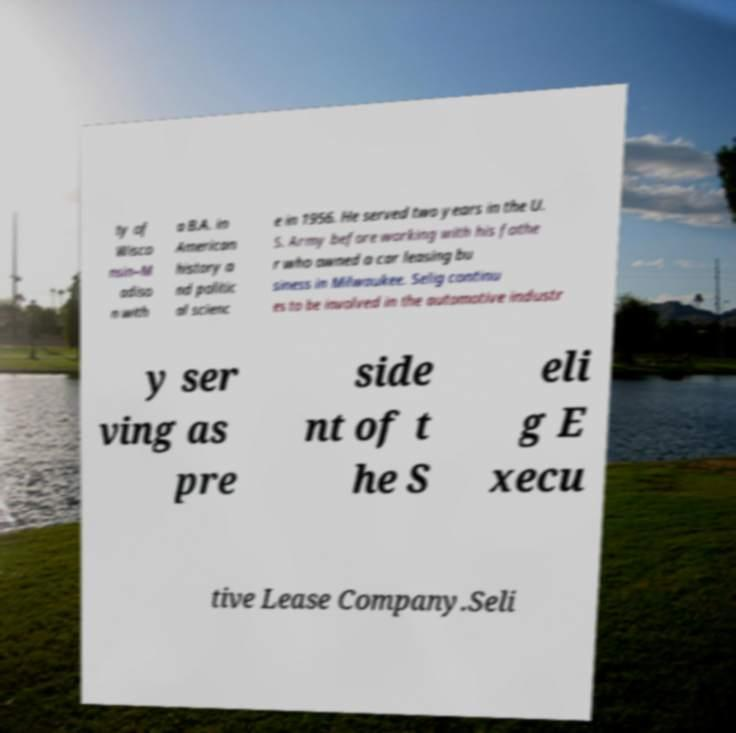Could you assist in decoding the text presented in this image and type it out clearly? ty of Wisco nsin–M adiso n with a B.A. in American history a nd politic al scienc e in 1956. He served two years in the U. S. Army before working with his fathe r who owned a car leasing bu siness in Milwaukee. Selig continu es to be involved in the automotive industr y ser ving as pre side nt of t he S eli g E xecu tive Lease Company.Seli 